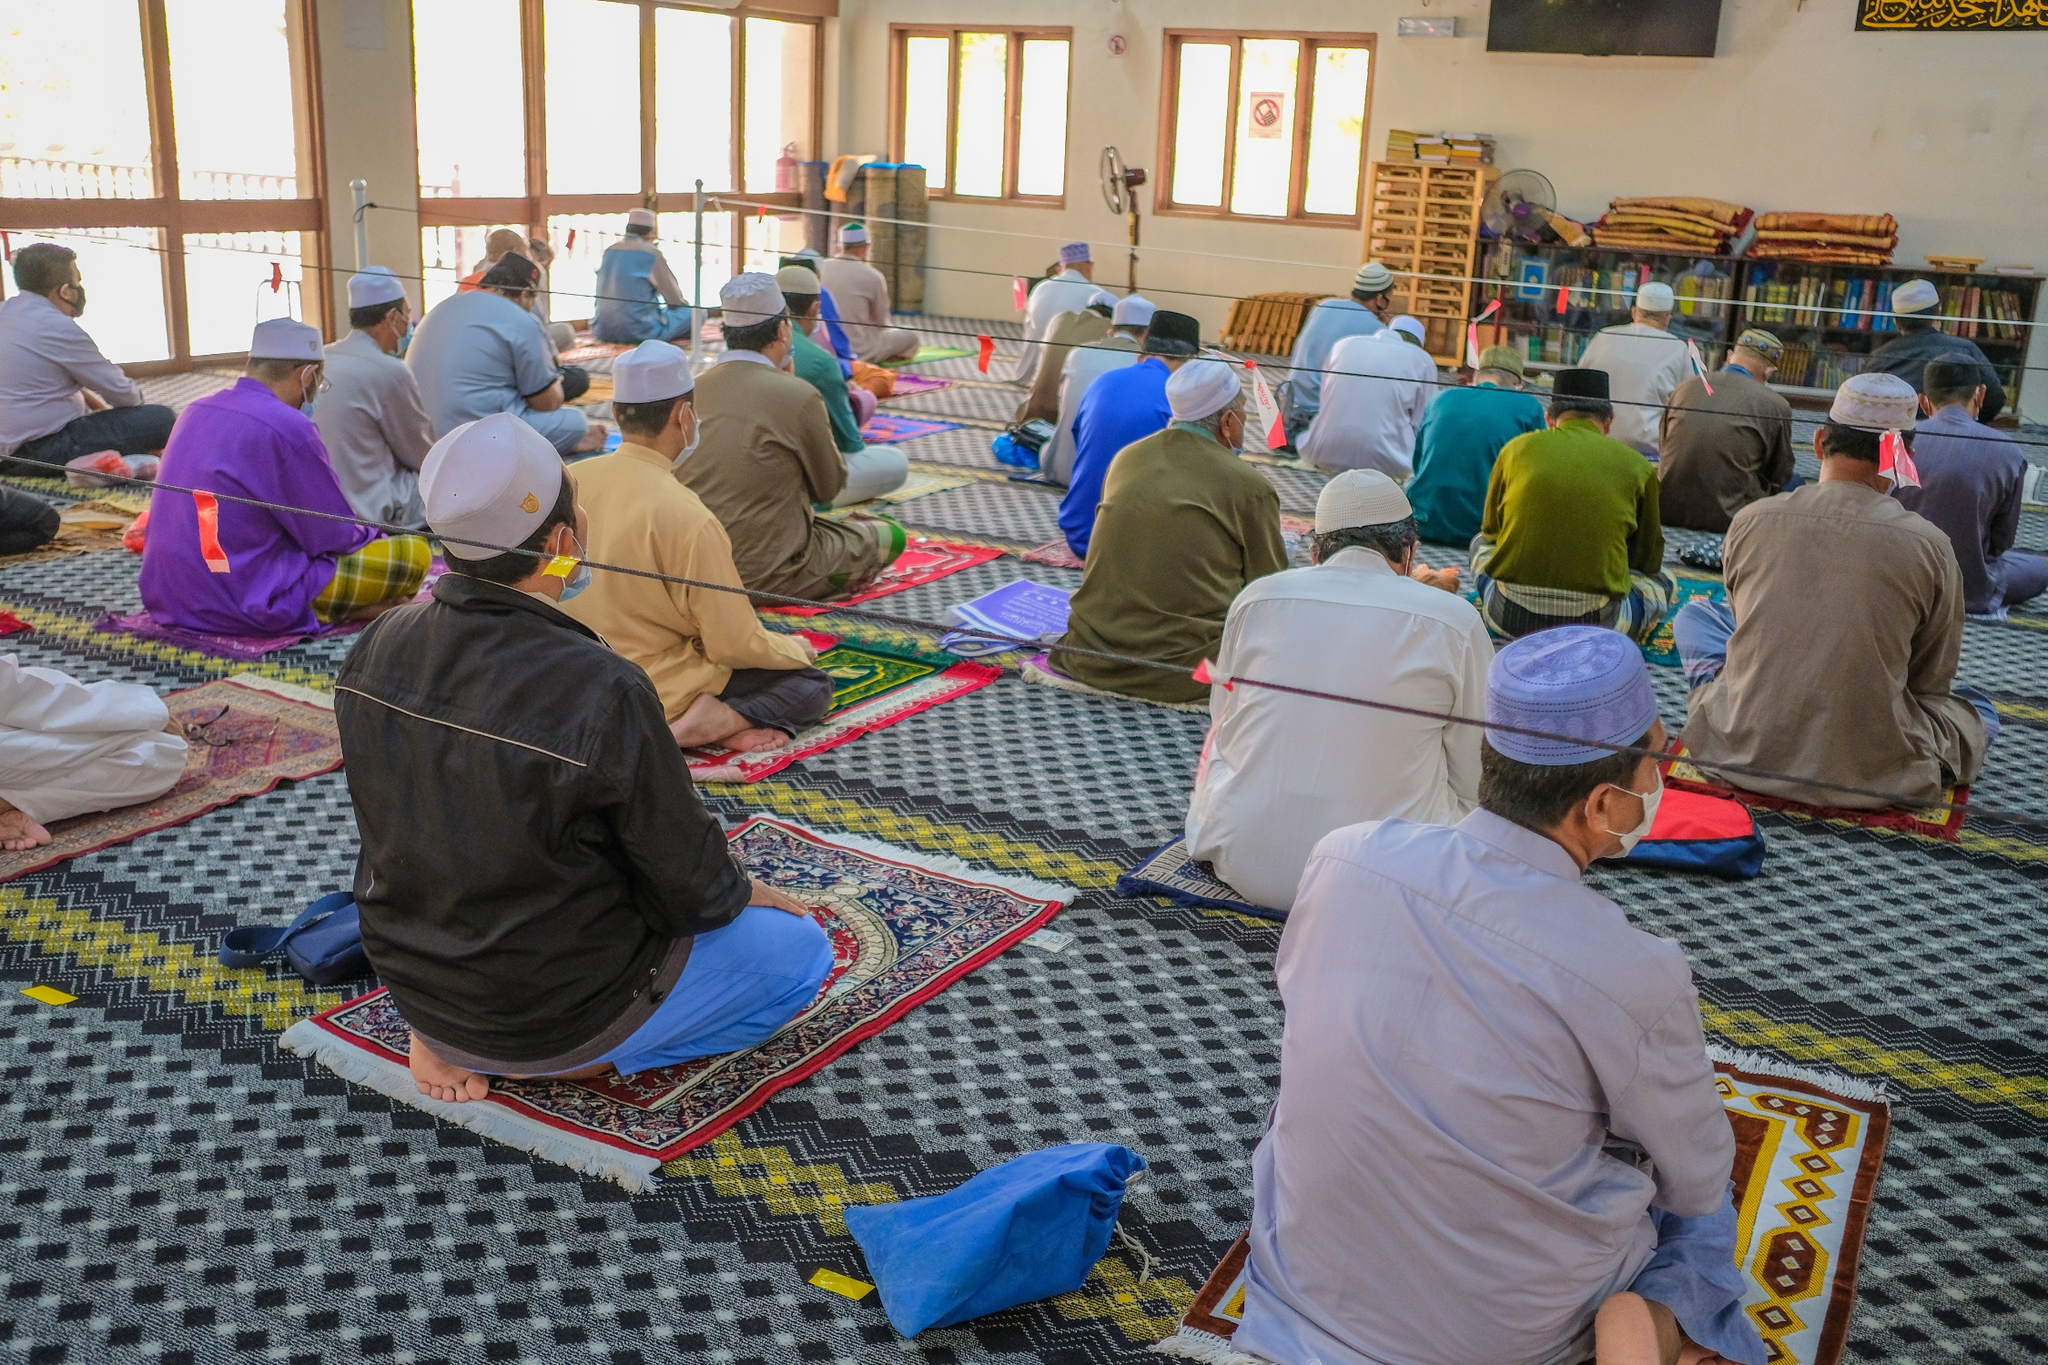What does this image tell us about community and individual responsibility? This image speaks volumes about the balance between community and individual responsibility. Within the mosque, the aligned rows of worshippers illustrate a strong sense of communal unity and collective practice in faith. The vibrant prayer rugs they sit on symbolize personal devotion and individual contribution to the broader spiritual tapestry. The presence of safety measures such as masks and distancing markers underscores each individual's responsibility towards the well-being of the community, highlighting an adaptive response to contemporary challenges. This amalgamation signifies that while spirituality brings people together, it also demands personal accountability for the health and harmony of the community. Can you describe a narrative inspired by this scene, focusing on one individual? In the heart of the bustling city, Ahmed found solace in the mosque. As dawn cracked, he slipped into the prayer hall, a haven where worries seemed to dissolve. Ahmed, a scientist by day, felt a deep connection to the spiritual practices passed down through generations. Each prayer session was a bridge connecting him to his ancestors, whispering ancient wisdom to his modern intellect. Sitting on a vibrant prayer rug, he felt the encompassing serenity as sunlight bathed the room. The soft hum of collective recitations wrapped around him like a comforting embrace. Ahmed’s eyes would often drift to the shelves lined with books, a reminder of his unending quest for knowledge, both divine and worldly. Amidst the communal prayers, his individual reflections on personal and collective responsibility found a harmonious balance. This space nurtured his dual existence, blending faith with intellect, community with individuality, tradition with innovation—each prayer solidifying his commitment to be a pillar both in the mosque and in the broader world. 